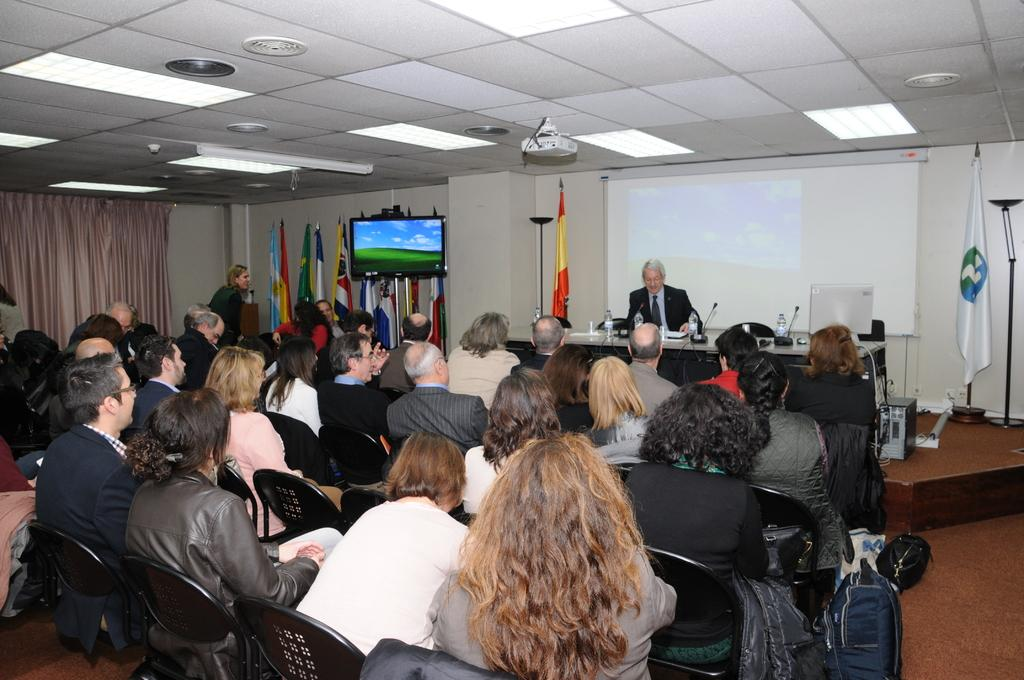What are the people in the image doing? The people in the image are sitting on chairs. Can you describe the person who is speaking in the image? There is a person sitting and talking into a microphone. What can be seen in the background of the image? There are flags visible in the image. What is the purpose of the display in the image? The purpose of the display in the image is not specified, but it could be used for presenting information or visuals. What type of shade is being provided for the beef in the image? There is no beef or shade present in the image. How many passengers are visible in the image? There are no passengers visible in the image; it features people sitting on chairs and a person speaking into a microphone. 